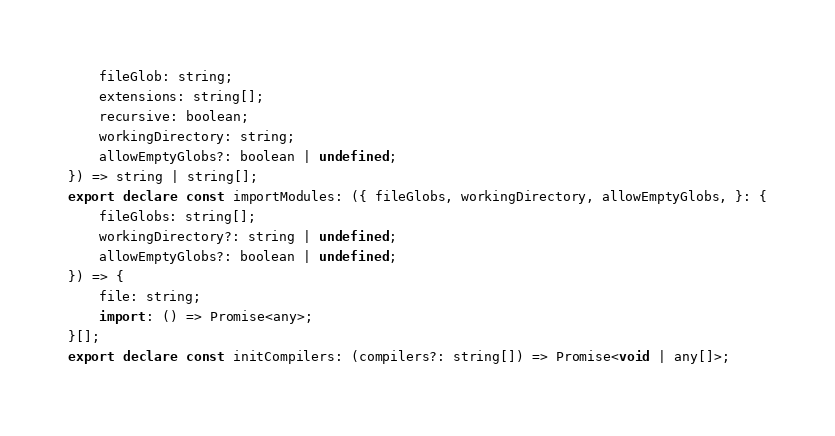<code> <loc_0><loc_0><loc_500><loc_500><_TypeScript_>    fileGlob: string;
    extensions: string[];
    recursive: boolean;
    workingDirectory: string;
    allowEmptyGlobs?: boolean | undefined;
}) => string | string[];
export declare const importModules: ({ fileGlobs, workingDirectory, allowEmptyGlobs, }: {
    fileGlobs: string[];
    workingDirectory?: string | undefined;
    allowEmptyGlobs?: boolean | undefined;
}) => {
    file: string;
    import: () => Promise<any>;
}[];
export declare const initCompilers: (compilers?: string[]) => Promise<void | any[]>;
</code> 